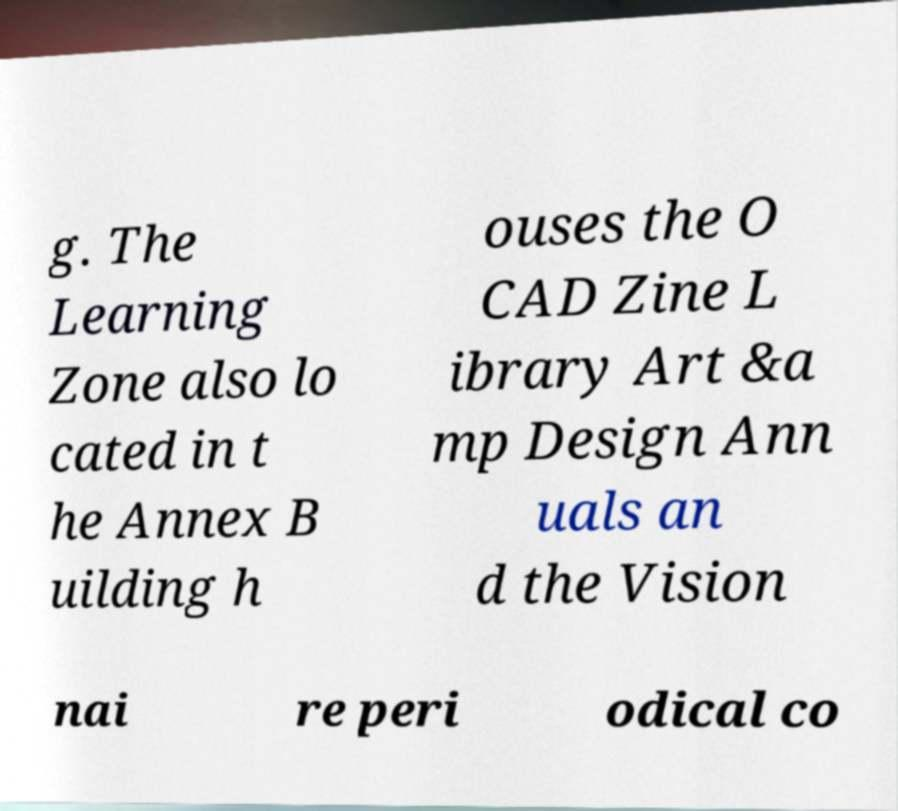Please identify and transcribe the text found in this image. g. The Learning Zone also lo cated in t he Annex B uilding h ouses the O CAD Zine L ibrary Art &a mp Design Ann uals an d the Vision nai re peri odical co 